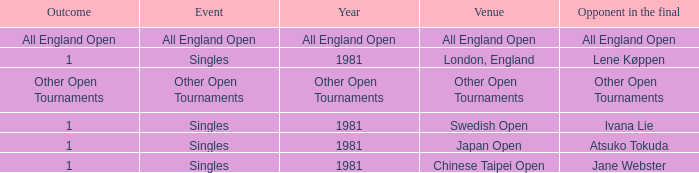What is the Outcome of the Singles Event in London, England? 1.0. 